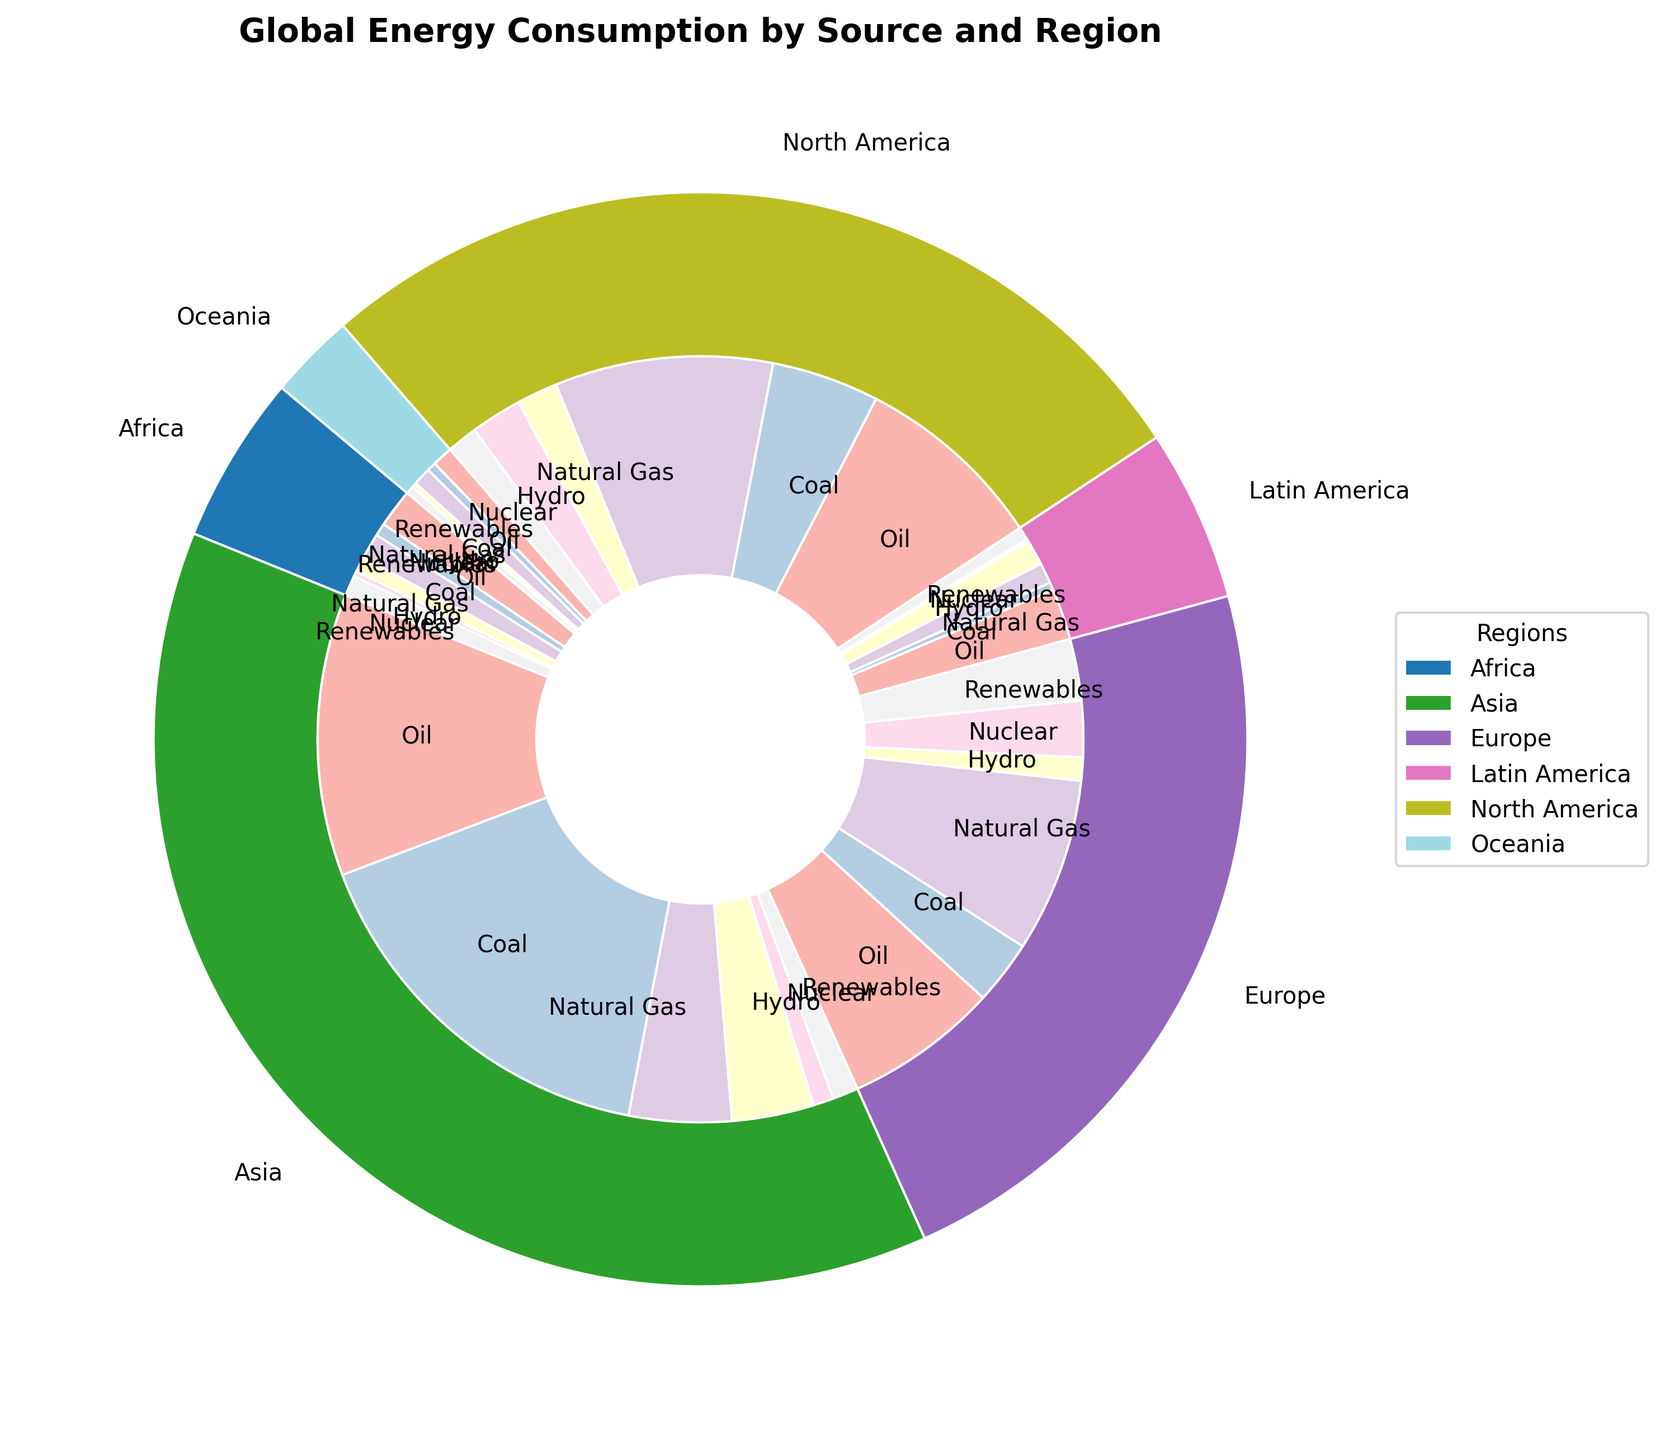Which region has the highest total energy consumption? By observing the outer ring of the pie chart, which represents regions, the largest wedge corresponds to Asia, indicating it has the highest total energy consumption.
Answer: Asia Which energy source is most consumed in North America? By looking at the inner wedges within the North America segment of the outer ring, the largest wedge corresponds to Natural Gas consumption.
Answer: Natural Gas What is the total energy consumption of Nuclear power in Europe and Asia combined? Identify the Nuclear consumption values for both Europe and Asia from the inner ring and sum them: Europe (2200 TWh) + Asia (800 TWh) = 3000 TWh.
Answer: 3000 TWh Compare the total consumption of Renewable energy in Europe with that in North America. Which is higher? Refer to the Renewable wedges within Europe and North America segments. Europe’s Renewable consumption is 2400 TWh, which is higher than North America’s 1200 TWh.
Answer: Europe How does the consumption of Coal in Asia compare to that in Latin America? By observing the inner wedges for Coal in both Asia and Latin America, Asia (15000 TWh) has significantly higher consumption than Latin America (300 TWh).
Answer: Asia is much higher Which region has the smallest portion of its energy consumption from Hydro? By examining the inner wedges representing Hydro within each region, Oceania’s Hydro segment is the smallest.
Answer: Oceania What is the sum of Oil consumption in Africa, Latin America, and Oceania? Add the Oil consumption values for each of these regions: Africa (1500 TWh) + Latin America (2000 TWh) + Oceania (800 TWh) = 4300 TWh.
Answer: 4300 TWh Which has a greater consumption in Europe: Natural Gas or Oil? Compare the wedges for Natural Gas and Oil within Europe. Natural Gas (6800 TWh) is greater than Oil (6000 TWh).
Answer: Natural Gas 